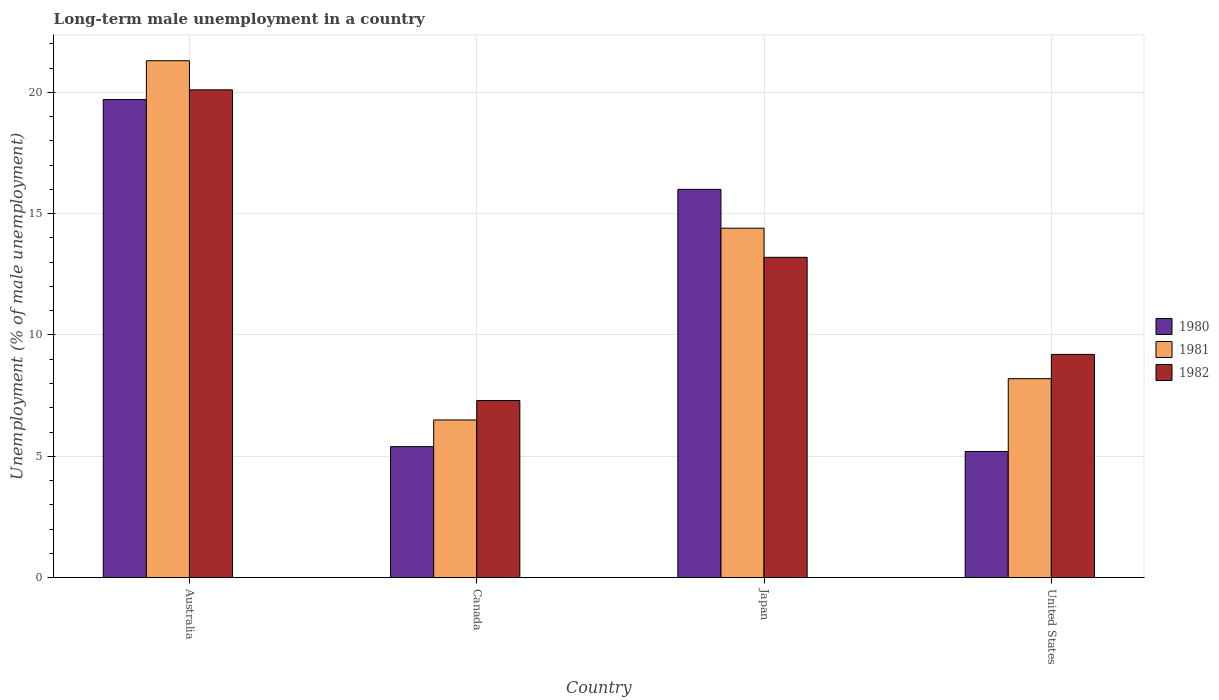How many groups of bars are there?
Provide a short and direct response. 4. Are the number of bars per tick equal to the number of legend labels?
Ensure brevity in your answer.  Yes. How many bars are there on the 1st tick from the left?
Ensure brevity in your answer.  3. In how many cases, is the number of bars for a given country not equal to the number of legend labels?
Offer a very short reply. 0. What is the percentage of long-term unemployed male population in 1980 in United States?
Keep it short and to the point. 5.2. Across all countries, what is the maximum percentage of long-term unemployed male population in 1982?
Give a very brief answer. 20.1. In which country was the percentage of long-term unemployed male population in 1981 maximum?
Make the answer very short. Australia. What is the total percentage of long-term unemployed male population in 1980 in the graph?
Offer a very short reply. 46.3. What is the difference between the percentage of long-term unemployed male population in 1982 in Australia and that in United States?
Make the answer very short. 10.9. What is the difference between the percentage of long-term unemployed male population in 1981 in Canada and the percentage of long-term unemployed male population in 1980 in United States?
Make the answer very short. 1.3. What is the average percentage of long-term unemployed male population in 1982 per country?
Provide a short and direct response. 12.45. What is the difference between the percentage of long-term unemployed male population of/in 1980 and percentage of long-term unemployed male population of/in 1981 in Australia?
Provide a succinct answer. -1.6. In how many countries, is the percentage of long-term unemployed male population in 1980 greater than 10 %?
Provide a succinct answer. 2. What is the ratio of the percentage of long-term unemployed male population in 1980 in Canada to that in Japan?
Provide a succinct answer. 0.34. Is the percentage of long-term unemployed male population in 1980 in Australia less than that in Canada?
Make the answer very short. No. Is the difference between the percentage of long-term unemployed male population in 1980 in Canada and United States greater than the difference between the percentage of long-term unemployed male population in 1981 in Canada and United States?
Ensure brevity in your answer.  Yes. What is the difference between the highest and the second highest percentage of long-term unemployed male population in 1982?
Your answer should be compact. -10.9. What is the difference between the highest and the lowest percentage of long-term unemployed male population in 1981?
Ensure brevity in your answer.  14.8. Is the sum of the percentage of long-term unemployed male population in 1981 in Canada and United States greater than the maximum percentage of long-term unemployed male population in 1980 across all countries?
Offer a very short reply. No. What does the 1st bar from the left in Australia represents?
Your answer should be very brief. 1980. What does the 3rd bar from the right in Canada represents?
Make the answer very short. 1980. How many bars are there?
Provide a succinct answer. 12. How many countries are there in the graph?
Offer a very short reply. 4. What is the difference between two consecutive major ticks on the Y-axis?
Provide a succinct answer. 5. Are the values on the major ticks of Y-axis written in scientific E-notation?
Provide a short and direct response. No. Does the graph contain any zero values?
Keep it short and to the point. No. Where does the legend appear in the graph?
Provide a succinct answer. Center right. How are the legend labels stacked?
Offer a very short reply. Vertical. What is the title of the graph?
Provide a short and direct response. Long-term male unemployment in a country. What is the label or title of the Y-axis?
Ensure brevity in your answer.  Unemployment (% of male unemployment). What is the Unemployment (% of male unemployment) of 1980 in Australia?
Give a very brief answer. 19.7. What is the Unemployment (% of male unemployment) in 1981 in Australia?
Provide a short and direct response. 21.3. What is the Unemployment (% of male unemployment) of 1982 in Australia?
Ensure brevity in your answer.  20.1. What is the Unemployment (% of male unemployment) in 1980 in Canada?
Ensure brevity in your answer.  5.4. What is the Unemployment (% of male unemployment) in 1982 in Canada?
Offer a very short reply. 7.3. What is the Unemployment (% of male unemployment) of 1980 in Japan?
Give a very brief answer. 16. What is the Unemployment (% of male unemployment) of 1981 in Japan?
Ensure brevity in your answer.  14.4. What is the Unemployment (% of male unemployment) of 1982 in Japan?
Give a very brief answer. 13.2. What is the Unemployment (% of male unemployment) in 1980 in United States?
Give a very brief answer. 5.2. What is the Unemployment (% of male unemployment) of 1981 in United States?
Offer a terse response. 8.2. What is the Unemployment (% of male unemployment) of 1982 in United States?
Give a very brief answer. 9.2. Across all countries, what is the maximum Unemployment (% of male unemployment) in 1980?
Ensure brevity in your answer.  19.7. Across all countries, what is the maximum Unemployment (% of male unemployment) in 1981?
Your answer should be compact. 21.3. Across all countries, what is the maximum Unemployment (% of male unemployment) of 1982?
Make the answer very short. 20.1. Across all countries, what is the minimum Unemployment (% of male unemployment) of 1980?
Provide a succinct answer. 5.2. Across all countries, what is the minimum Unemployment (% of male unemployment) in 1981?
Your response must be concise. 6.5. Across all countries, what is the minimum Unemployment (% of male unemployment) in 1982?
Your answer should be compact. 7.3. What is the total Unemployment (% of male unemployment) in 1980 in the graph?
Offer a terse response. 46.3. What is the total Unemployment (% of male unemployment) of 1981 in the graph?
Your answer should be compact. 50.4. What is the total Unemployment (% of male unemployment) of 1982 in the graph?
Provide a succinct answer. 49.8. What is the difference between the Unemployment (% of male unemployment) in 1980 in Australia and that in Canada?
Give a very brief answer. 14.3. What is the difference between the Unemployment (% of male unemployment) of 1981 in Australia and that in Canada?
Provide a succinct answer. 14.8. What is the difference between the Unemployment (% of male unemployment) in 1982 in Australia and that in Canada?
Offer a very short reply. 12.8. What is the difference between the Unemployment (% of male unemployment) in 1982 in Australia and that in Japan?
Provide a short and direct response. 6.9. What is the difference between the Unemployment (% of male unemployment) in 1980 in Australia and that in United States?
Your response must be concise. 14.5. What is the difference between the Unemployment (% of male unemployment) of 1981 in Australia and that in United States?
Offer a terse response. 13.1. What is the difference between the Unemployment (% of male unemployment) of 1982 in Australia and that in United States?
Provide a short and direct response. 10.9. What is the difference between the Unemployment (% of male unemployment) in 1980 in Canada and that in Japan?
Offer a terse response. -10.6. What is the difference between the Unemployment (% of male unemployment) in 1980 in Canada and that in United States?
Give a very brief answer. 0.2. What is the difference between the Unemployment (% of male unemployment) in 1981 in Canada and that in United States?
Provide a short and direct response. -1.7. What is the difference between the Unemployment (% of male unemployment) in 1980 in Australia and the Unemployment (% of male unemployment) in 1982 in Canada?
Give a very brief answer. 12.4. What is the difference between the Unemployment (% of male unemployment) of 1981 in Australia and the Unemployment (% of male unemployment) of 1982 in Canada?
Provide a succinct answer. 14. What is the difference between the Unemployment (% of male unemployment) of 1980 in Australia and the Unemployment (% of male unemployment) of 1982 in Japan?
Offer a very short reply. 6.5. What is the difference between the Unemployment (% of male unemployment) of 1980 in Australia and the Unemployment (% of male unemployment) of 1981 in United States?
Give a very brief answer. 11.5. What is the difference between the Unemployment (% of male unemployment) in 1980 in Australia and the Unemployment (% of male unemployment) in 1982 in United States?
Keep it short and to the point. 10.5. What is the difference between the Unemployment (% of male unemployment) in 1980 in Canada and the Unemployment (% of male unemployment) in 1981 in Japan?
Your response must be concise. -9. What is the difference between the Unemployment (% of male unemployment) of 1980 in Canada and the Unemployment (% of male unemployment) of 1982 in Japan?
Offer a very short reply. -7.8. What is the difference between the Unemployment (% of male unemployment) of 1981 in Canada and the Unemployment (% of male unemployment) of 1982 in Japan?
Provide a succinct answer. -6.7. What is the difference between the Unemployment (% of male unemployment) of 1980 in Canada and the Unemployment (% of male unemployment) of 1981 in United States?
Ensure brevity in your answer.  -2.8. What is the difference between the Unemployment (% of male unemployment) of 1980 in Canada and the Unemployment (% of male unemployment) of 1982 in United States?
Provide a succinct answer. -3.8. What is the difference between the Unemployment (% of male unemployment) in 1981 in Canada and the Unemployment (% of male unemployment) in 1982 in United States?
Offer a very short reply. -2.7. What is the difference between the Unemployment (% of male unemployment) of 1980 in Japan and the Unemployment (% of male unemployment) of 1982 in United States?
Offer a terse response. 6.8. What is the average Unemployment (% of male unemployment) of 1980 per country?
Keep it short and to the point. 11.57. What is the average Unemployment (% of male unemployment) of 1981 per country?
Provide a succinct answer. 12.6. What is the average Unemployment (% of male unemployment) in 1982 per country?
Offer a very short reply. 12.45. What is the difference between the Unemployment (% of male unemployment) of 1980 and Unemployment (% of male unemployment) of 1981 in Australia?
Give a very brief answer. -1.6. What is the difference between the Unemployment (% of male unemployment) in 1980 and Unemployment (% of male unemployment) in 1982 in Australia?
Provide a succinct answer. -0.4. What is the difference between the Unemployment (% of male unemployment) in 1980 and Unemployment (% of male unemployment) in 1982 in Canada?
Ensure brevity in your answer.  -1.9. What is the difference between the Unemployment (% of male unemployment) in 1980 and Unemployment (% of male unemployment) in 1981 in Japan?
Your answer should be very brief. 1.6. What is the difference between the Unemployment (% of male unemployment) of 1980 and Unemployment (% of male unemployment) of 1982 in Japan?
Offer a very short reply. 2.8. What is the ratio of the Unemployment (% of male unemployment) of 1980 in Australia to that in Canada?
Make the answer very short. 3.65. What is the ratio of the Unemployment (% of male unemployment) in 1981 in Australia to that in Canada?
Give a very brief answer. 3.28. What is the ratio of the Unemployment (% of male unemployment) in 1982 in Australia to that in Canada?
Offer a terse response. 2.75. What is the ratio of the Unemployment (% of male unemployment) of 1980 in Australia to that in Japan?
Offer a terse response. 1.23. What is the ratio of the Unemployment (% of male unemployment) in 1981 in Australia to that in Japan?
Make the answer very short. 1.48. What is the ratio of the Unemployment (% of male unemployment) in 1982 in Australia to that in Japan?
Offer a very short reply. 1.52. What is the ratio of the Unemployment (% of male unemployment) in 1980 in Australia to that in United States?
Provide a succinct answer. 3.79. What is the ratio of the Unemployment (% of male unemployment) in 1981 in Australia to that in United States?
Your answer should be compact. 2.6. What is the ratio of the Unemployment (% of male unemployment) in 1982 in Australia to that in United States?
Keep it short and to the point. 2.18. What is the ratio of the Unemployment (% of male unemployment) of 1980 in Canada to that in Japan?
Keep it short and to the point. 0.34. What is the ratio of the Unemployment (% of male unemployment) of 1981 in Canada to that in Japan?
Your response must be concise. 0.45. What is the ratio of the Unemployment (% of male unemployment) of 1982 in Canada to that in Japan?
Your response must be concise. 0.55. What is the ratio of the Unemployment (% of male unemployment) in 1981 in Canada to that in United States?
Keep it short and to the point. 0.79. What is the ratio of the Unemployment (% of male unemployment) of 1982 in Canada to that in United States?
Make the answer very short. 0.79. What is the ratio of the Unemployment (% of male unemployment) of 1980 in Japan to that in United States?
Your answer should be compact. 3.08. What is the ratio of the Unemployment (% of male unemployment) of 1981 in Japan to that in United States?
Your answer should be compact. 1.76. What is the ratio of the Unemployment (% of male unemployment) in 1982 in Japan to that in United States?
Give a very brief answer. 1.43. What is the difference between the highest and the second highest Unemployment (% of male unemployment) in 1982?
Keep it short and to the point. 6.9. 